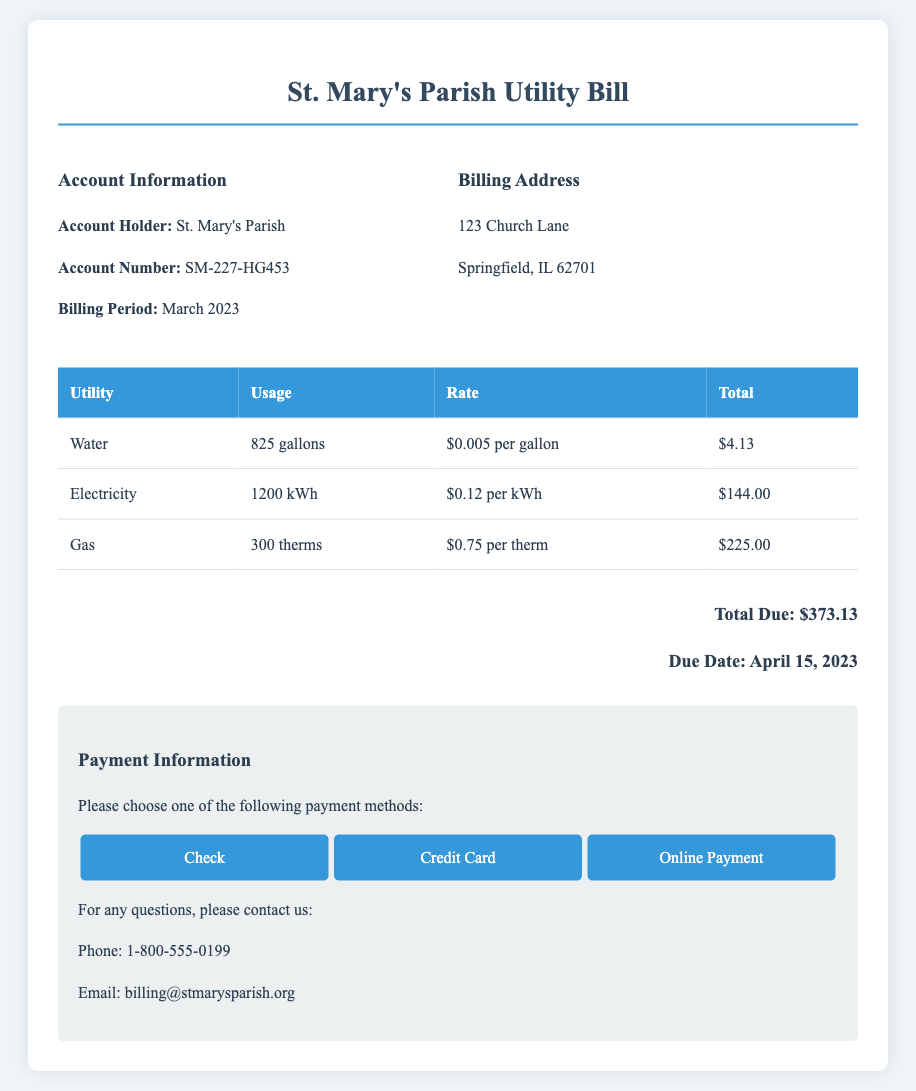What is the account holder's name? The account holder's name is provided in the "Account Information" section of the document.
Answer: St. Mary's Parish What is the total amount due? The total amount due is stated at the end of the bill, summing up all utility charges.
Answer: $373.13 What is the billing address? The billing address can be found in the "Billing Address" section of the document.
Answer: 123 Church Lane, Springfield, IL 62701 How much is charged per galloon of water? The rate charged for water can be found in the breakdown of utility charges.
Answer: $0.005 per gallon What is the usage of electricity? The electricity usage is detailed in the table under "Electricity."
Answer: 1200 kWh What is the rate for gas? The rate for gas can be found in the utility charges table for gas.
Answer: $0.75 per therm What percentage of the total bill is from electricity charges? To find this percentage, calculate the total electricity charge divided by the total bill amount, then multiply by 100.
Answer: 38.6% When is the due date for the bill? The due date is explicitly mentioned at the end of the document.
Answer: April 15, 2023 What payment methods are available? The payment methods are listed in the "Payment Information" section of the document.
Answer: Check, Credit Card, Online Payment 